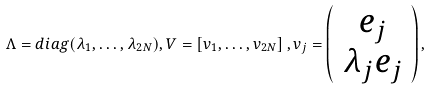Convert formula to latex. <formula><loc_0><loc_0><loc_500><loc_500>\Lambda = d i a g ( \lambda _ { 1 } , \dots , \lambda _ { 2 N } ) , V = \left [ v _ { 1 } , \dots , v _ { 2 N } \right ] , v _ { j } = \left ( \begin{array} { c } e _ { j } \\ \lambda _ { j } e _ { j } \end{array} \right ) ,</formula> 